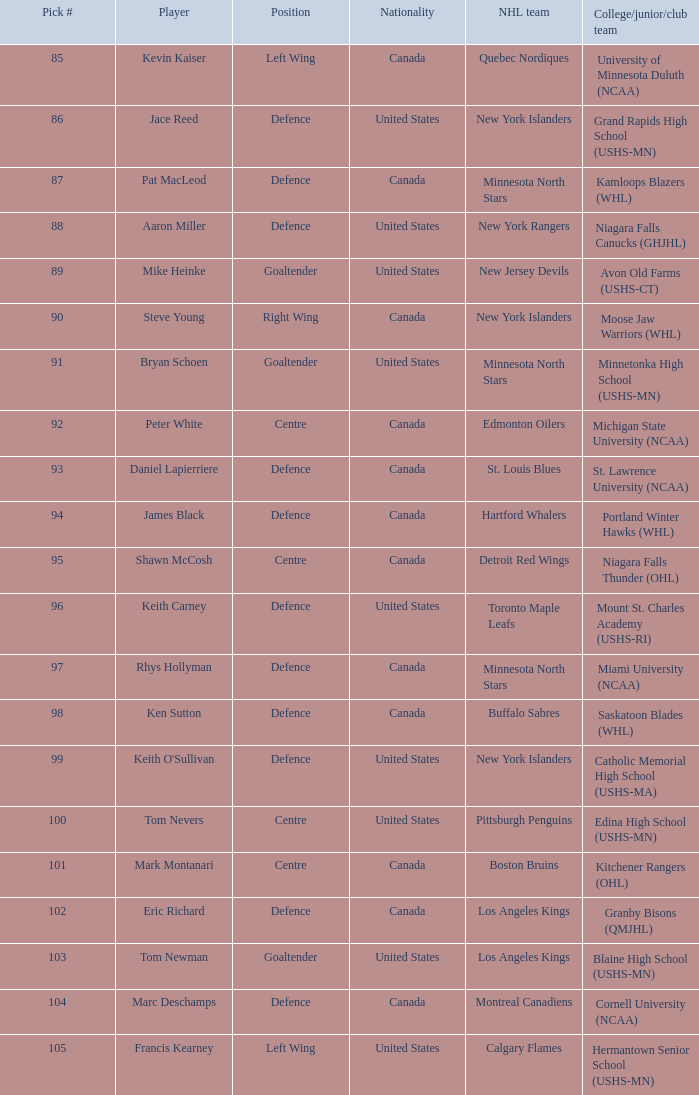What player attended avon old farms (ushs-ct)? Mike Heinke. 